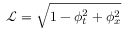<formula> <loc_0><loc_0><loc_500><loc_500>\mathcal { L } = \sqrt { 1 - \phi _ { t } ^ { 2 } + \phi _ { x } ^ { 2 } }</formula> 